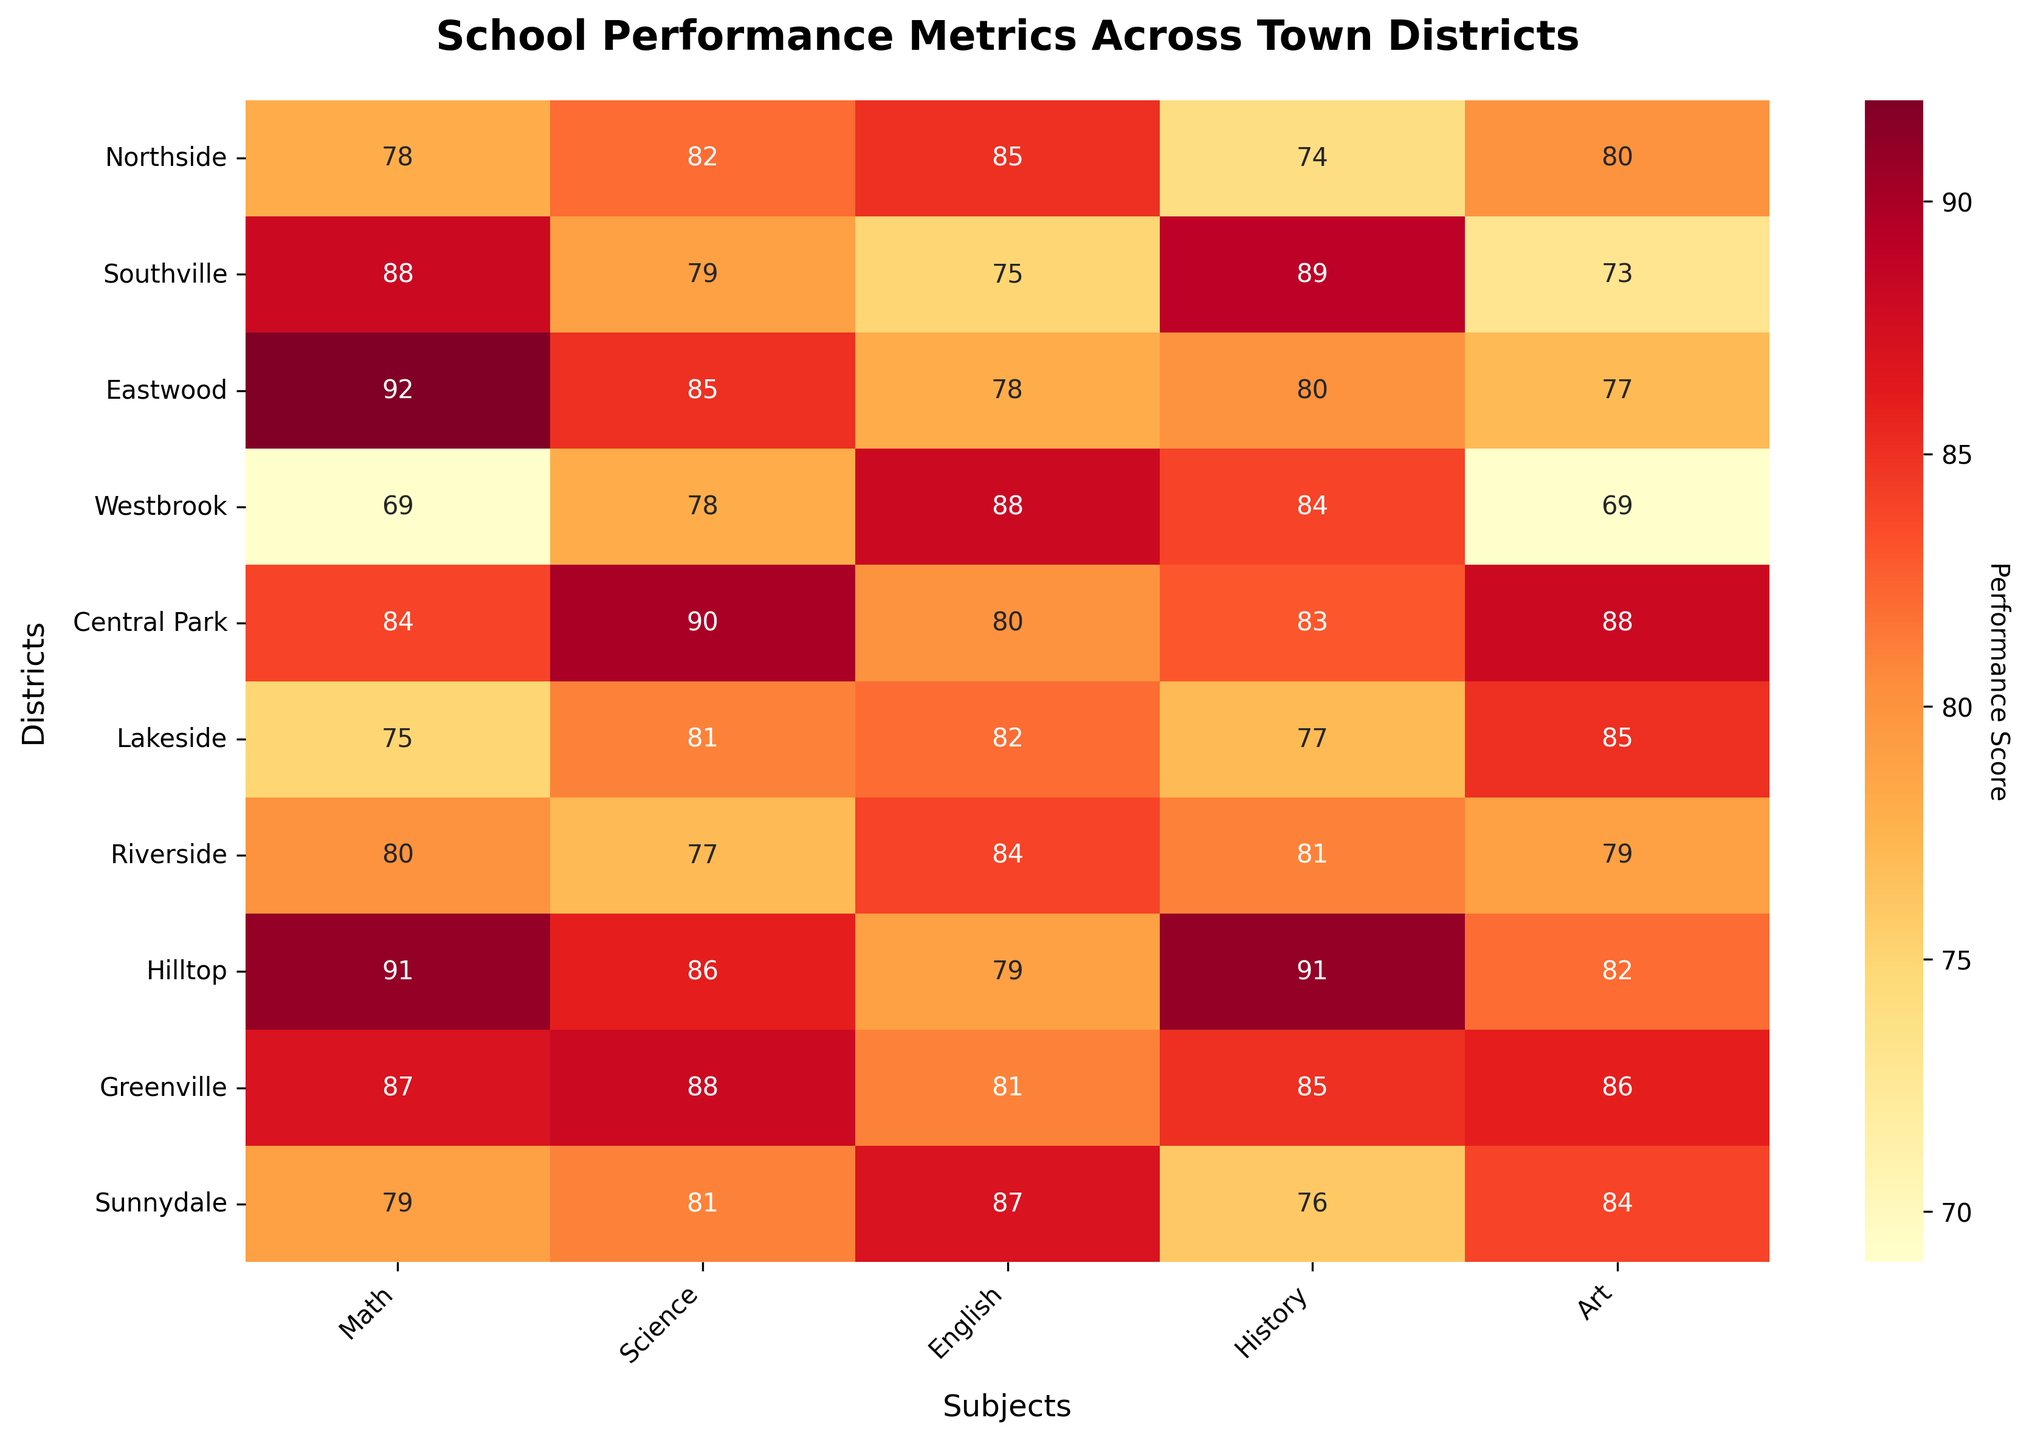What is the title of the heatmap? The title of a plot is typically found at the top and gives an overall idea of what it represents. In this case, it reads "School Performance Metrics Across Town Districts".
Answer: School Performance Metrics Across Town Districts Which district has the highest score in Math? To find this, look at the Math column and identify the highest number. The highest score is 92, which is achieved by Eastwood.
Answer: Eastwood What is the average English score across all districts? To calculate the average, sum up the scores in the English column and divide by the number of districts. (85 + 75 + 78 + 88 + 80 + 82 + 84 + 79 + 81 + 87) / 10 = 819 / 10 = 81.9
Answer: 81.9 Which district has the lowest score in History? To find this, examine the History column and locate the lowest number. The lowest score is 74, which belongs to Northside.
Answer: Northside How does the Art performance in Central Park compare to that in Westbrook? Look at the Art scores for both Central Park and Westbrook. Central Park has a score of 88, while Westbrook has a score of 69. Therefore, Central Park has a higher performance in Art than Westbrook.
Answer: Central Park performs better What is the range of scores for Science across the districts? The range is found by subtracting the smallest score from the largest score in the Science column. The highest score is 90 (Central Park) and the lowest is 77 (Riverside). So, the range is 90 - 77 = 13.
Answer: 13 Which subject shows the most consistent performance across all districts? Consistency can be inferred by examining the spread of scores in each subject's column. For example, Science scores range from 77 to 90, a range of 13. Other subjects have larger ranges, so Science shows the most consistency.
Answer: Science How many subjects did Hilltop score above 85? Look at Hilltop's row and count the subjects with scores above 85. Hilltop scores: Math (91), Science (86), English (79), History (91), Art (82). There are three subjects with scores above 85: Math, Science, and History.
Answer: 3 Which district has the most varied performance (largest range) across subjects? Calculate the range for each district by subtracting its lowest score from its highest score. Then identify which district has the largest range. For example, Eastwood's highest is 92 (Math) and lowest is 77 (Art) giving a range of 15. Perform this for all districts; Eastwood has the largest range.
Answer: Eastwood What is the median score for Art across all districts? To find the median, list all Art scores in ascending order: 69, 73, 77, 79, 80, 82, 84, 85, 86, 88. The middle value is the average of the fifth and sixth scores: (80 + 82) / 2 = 81.
Answer: 81 